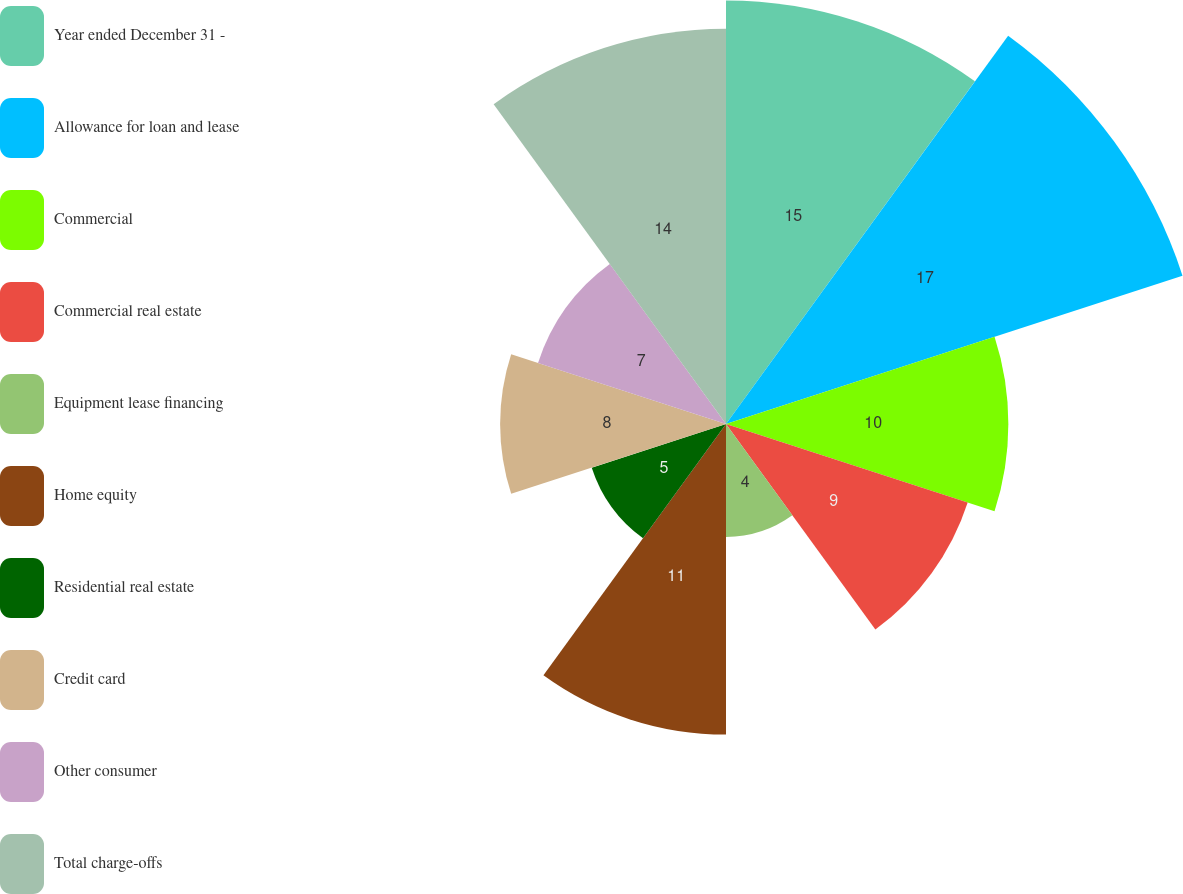Convert chart to OTSL. <chart><loc_0><loc_0><loc_500><loc_500><pie_chart><fcel>Year ended December 31 -<fcel>Allowance for loan and lease<fcel>Commercial<fcel>Commercial real estate<fcel>Equipment lease financing<fcel>Home equity<fcel>Residential real estate<fcel>Credit card<fcel>Other consumer<fcel>Total charge-offs<nl><fcel>15.0%<fcel>17.0%<fcel>10.0%<fcel>9.0%<fcel>4.0%<fcel>11.0%<fcel>5.0%<fcel>8.0%<fcel>7.0%<fcel>14.0%<nl></chart> 